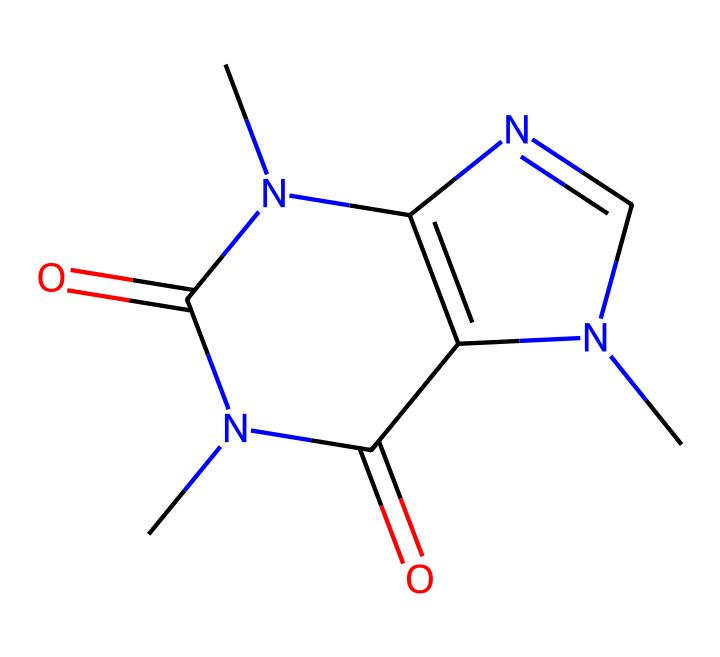What is the molecular formula of this compound? By analyzing the SMILES representation provided, we can identify that the compound contains 8 carbon atoms, 10 hydrogen atoms, 4 nitrogen atoms, and 2 oxygen atoms. Therefore, the molecular formula can be written as C8H10N4O2.
Answer: C8H10N4O2 How many nitrogen atoms are present in the structure? In the provided SMILES representation, the number of nitrogen atoms can be directly counted. The "N" symbols in the structure indicate 4 nitrogen atoms present.
Answer: 4 Is this compound a base or an acid? The presence of multiple nitrogen atoms in the structure, along with the cage arrangement, typically indicates that the compound behaves as a base, as nitrogen can donate electron pairs.
Answer: base What type of compound is caffeine classified as? Caffeine is classified as an alkaloid, which is a naturally occurring compound that contains basic nitrogen atoms. The cage structure and nitrogen presence further confirm this classification.
Answer: alkaloid Can this compound be found in energy drinks? Yes, caffeine is widely recognized and is a common stimulant found in many energy drinks, contributing to increased alertness and focus.
Answer: yes How many rings are in the chemical structure? The SMILES representation indicates that there are two interconnected ring systems (circular arrangements of atoms) present in this compound, characteristic of cage compounds like caffeine.
Answer: 2 What role does caffeine play in energy drinks? Caffeine serves as a stimulant, enhancing alertness and reducing fatigue, which makes it a popular ingredient in energy drinks for individuals looking to boost productivity.
Answer: stimulant 